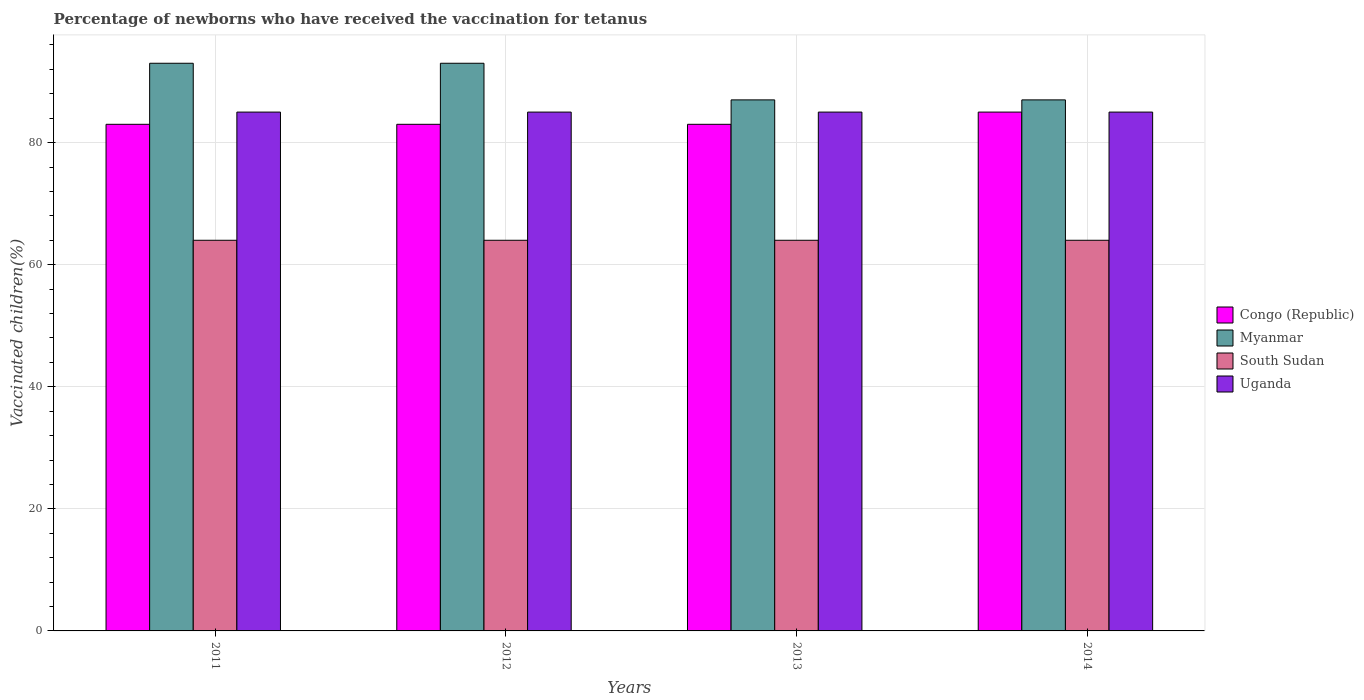Are the number of bars per tick equal to the number of legend labels?
Keep it short and to the point. Yes. Are the number of bars on each tick of the X-axis equal?
Give a very brief answer. Yes. In how many cases, is the number of bars for a given year not equal to the number of legend labels?
Your answer should be compact. 0. What is the percentage of vaccinated children in Congo (Republic) in 2011?
Your answer should be compact. 83. Across all years, what is the maximum percentage of vaccinated children in Uganda?
Keep it short and to the point. 85. Across all years, what is the minimum percentage of vaccinated children in Uganda?
Your answer should be very brief. 85. In which year was the percentage of vaccinated children in Myanmar maximum?
Your answer should be very brief. 2011. What is the total percentage of vaccinated children in Uganda in the graph?
Give a very brief answer. 340. What is the difference between the percentage of vaccinated children in Uganda in 2012 and that in 2013?
Offer a very short reply. 0. What is the ratio of the percentage of vaccinated children in South Sudan in 2013 to that in 2014?
Your answer should be very brief. 1. Is the difference between the percentage of vaccinated children in Uganda in 2011 and 2013 greater than the difference between the percentage of vaccinated children in Congo (Republic) in 2011 and 2013?
Ensure brevity in your answer.  No. What is the difference between the highest and the lowest percentage of vaccinated children in South Sudan?
Offer a very short reply. 0. In how many years, is the percentage of vaccinated children in Myanmar greater than the average percentage of vaccinated children in Myanmar taken over all years?
Ensure brevity in your answer.  2. Is it the case that in every year, the sum of the percentage of vaccinated children in Myanmar and percentage of vaccinated children in Uganda is greater than the sum of percentage of vaccinated children in South Sudan and percentage of vaccinated children in Congo (Republic)?
Your answer should be very brief. Yes. What does the 3rd bar from the left in 2014 represents?
Offer a very short reply. South Sudan. What does the 4th bar from the right in 2011 represents?
Keep it short and to the point. Congo (Republic). Is it the case that in every year, the sum of the percentage of vaccinated children in Congo (Republic) and percentage of vaccinated children in South Sudan is greater than the percentage of vaccinated children in Uganda?
Ensure brevity in your answer.  Yes. How many bars are there?
Make the answer very short. 16. Are all the bars in the graph horizontal?
Keep it short and to the point. No. What is the difference between two consecutive major ticks on the Y-axis?
Keep it short and to the point. 20. Does the graph contain any zero values?
Offer a very short reply. No. Does the graph contain grids?
Keep it short and to the point. Yes. How many legend labels are there?
Keep it short and to the point. 4. What is the title of the graph?
Offer a terse response. Percentage of newborns who have received the vaccination for tetanus. What is the label or title of the Y-axis?
Your answer should be compact. Vaccinated children(%). What is the Vaccinated children(%) of Myanmar in 2011?
Provide a succinct answer. 93. What is the Vaccinated children(%) in South Sudan in 2011?
Give a very brief answer. 64. What is the Vaccinated children(%) in Congo (Republic) in 2012?
Your answer should be very brief. 83. What is the Vaccinated children(%) in Myanmar in 2012?
Your answer should be compact. 93. What is the Vaccinated children(%) in South Sudan in 2012?
Give a very brief answer. 64. What is the Vaccinated children(%) in Myanmar in 2013?
Make the answer very short. 87. What is the Vaccinated children(%) of Congo (Republic) in 2014?
Make the answer very short. 85. What is the Vaccinated children(%) in Myanmar in 2014?
Provide a succinct answer. 87. What is the Vaccinated children(%) of South Sudan in 2014?
Your response must be concise. 64. What is the Vaccinated children(%) in Uganda in 2014?
Make the answer very short. 85. Across all years, what is the maximum Vaccinated children(%) of Myanmar?
Make the answer very short. 93. Across all years, what is the maximum Vaccinated children(%) of South Sudan?
Ensure brevity in your answer.  64. Across all years, what is the maximum Vaccinated children(%) in Uganda?
Provide a succinct answer. 85. Across all years, what is the minimum Vaccinated children(%) of Congo (Republic)?
Your answer should be compact. 83. What is the total Vaccinated children(%) of Congo (Republic) in the graph?
Ensure brevity in your answer.  334. What is the total Vaccinated children(%) of Myanmar in the graph?
Offer a very short reply. 360. What is the total Vaccinated children(%) in South Sudan in the graph?
Provide a succinct answer. 256. What is the total Vaccinated children(%) of Uganda in the graph?
Offer a very short reply. 340. What is the difference between the Vaccinated children(%) of Congo (Republic) in 2011 and that in 2012?
Your response must be concise. 0. What is the difference between the Vaccinated children(%) of Myanmar in 2011 and that in 2012?
Offer a terse response. 0. What is the difference between the Vaccinated children(%) in South Sudan in 2011 and that in 2012?
Ensure brevity in your answer.  0. What is the difference between the Vaccinated children(%) of Uganda in 2011 and that in 2012?
Make the answer very short. 0. What is the difference between the Vaccinated children(%) of South Sudan in 2011 and that in 2014?
Your answer should be compact. 0. What is the difference between the Vaccinated children(%) in Congo (Republic) in 2012 and that in 2013?
Make the answer very short. 0. What is the difference between the Vaccinated children(%) of Myanmar in 2012 and that in 2014?
Offer a very short reply. 6. What is the difference between the Vaccinated children(%) in Uganda in 2012 and that in 2014?
Provide a short and direct response. 0. What is the difference between the Vaccinated children(%) of South Sudan in 2013 and that in 2014?
Ensure brevity in your answer.  0. What is the difference between the Vaccinated children(%) of Uganda in 2013 and that in 2014?
Ensure brevity in your answer.  0. What is the difference between the Vaccinated children(%) of Myanmar in 2011 and the Vaccinated children(%) of South Sudan in 2012?
Your response must be concise. 29. What is the difference between the Vaccinated children(%) of Myanmar in 2011 and the Vaccinated children(%) of Uganda in 2012?
Ensure brevity in your answer.  8. What is the difference between the Vaccinated children(%) in Congo (Republic) in 2011 and the Vaccinated children(%) in Myanmar in 2013?
Make the answer very short. -4. What is the difference between the Vaccinated children(%) in Myanmar in 2011 and the Vaccinated children(%) in Uganda in 2013?
Give a very brief answer. 8. What is the difference between the Vaccinated children(%) in South Sudan in 2011 and the Vaccinated children(%) in Uganda in 2013?
Offer a very short reply. -21. What is the difference between the Vaccinated children(%) of Congo (Republic) in 2011 and the Vaccinated children(%) of Myanmar in 2014?
Provide a succinct answer. -4. What is the difference between the Vaccinated children(%) in Congo (Republic) in 2011 and the Vaccinated children(%) in Uganda in 2014?
Provide a succinct answer. -2. What is the difference between the Vaccinated children(%) of Myanmar in 2011 and the Vaccinated children(%) of South Sudan in 2014?
Your answer should be very brief. 29. What is the difference between the Vaccinated children(%) of Myanmar in 2011 and the Vaccinated children(%) of Uganda in 2014?
Your answer should be very brief. 8. What is the difference between the Vaccinated children(%) of South Sudan in 2011 and the Vaccinated children(%) of Uganda in 2014?
Your answer should be compact. -21. What is the difference between the Vaccinated children(%) in Congo (Republic) in 2012 and the Vaccinated children(%) in Myanmar in 2013?
Your answer should be compact. -4. What is the difference between the Vaccinated children(%) in Congo (Republic) in 2012 and the Vaccinated children(%) in Uganda in 2013?
Ensure brevity in your answer.  -2. What is the difference between the Vaccinated children(%) in Congo (Republic) in 2012 and the Vaccinated children(%) in Uganda in 2014?
Ensure brevity in your answer.  -2. What is the difference between the Vaccinated children(%) in Myanmar in 2012 and the Vaccinated children(%) in Uganda in 2014?
Ensure brevity in your answer.  8. What is the difference between the Vaccinated children(%) of South Sudan in 2012 and the Vaccinated children(%) of Uganda in 2014?
Offer a very short reply. -21. What is the difference between the Vaccinated children(%) of Congo (Republic) in 2013 and the Vaccinated children(%) of Myanmar in 2014?
Give a very brief answer. -4. What is the difference between the Vaccinated children(%) of Myanmar in 2013 and the Vaccinated children(%) of Uganda in 2014?
Offer a very short reply. 2. What is the difference between the Vaccinated children(%) in South Sudan in 2013 and the Vaccinated children(%) in Uganda in 2014?
Provide a succinct answer. -21. What is the average Vaccinated children(%) of Congo (Republic) per year?
Keep it short and to the point. 83.5. What is the average Vaccinated children(%) in Myanmar per year?
Keep it short and to the point. 90. What is the average Vaccinated children(%) in South Sudan per year?
Make the answer very short. 64. In the year 2011, what is the difference between the Vaccinated children(%) in Congo (Republic) and Vaccinated children(%) in South Sudan?
Provide a short and direct response. 19. In the year 2011, what is the difference between the Vaccinated children(%) of Myanmar and Vaccinated children(%) of Uganda?
Offer a terse response. 8. In the year 2011, what is the difference between the Vaccinated children(%) of South Sudan and Vaccinated children(%) of Uganda?
Ensure brevity in your answer.  -21. In the year 2012, what is the difference between the Vaccinated children(%) in Congo (Republic) and Vaccinated children(%) in Myanmar?
Give a very brief answer. -10. In the year 2012, what is the difference between the Vaccinated children(%) of Congo (Republic) and Vaccinated children(%) of Uganda?
Give a very brief answer. -2. In the year 2012, what is the difference between the Vaccinated children(%) of Myanmar and Vaccinated children(%) of South Sudan?
Offer a terse response. 29. In the year 2012, what is the difference between the Vaccinated children(%) in South Sudan and Vaccinated children(%) in Uganda?
Offer a terse response. -21. In the year 2013, what is the difference between the Vaccinated children(%) of Congo (Republic) and Vaccinated children(%) of South Sudan?
Provide a short and direct response. 19. In the year 2013, what is the difference between the Vaccinated children(%) in Congo (Republic) and Vaccinated children(%) in Uganda?
Give a very brief answer. -2. In the year 2013, what is the difference between the Vaccinated children(%) of Myanmar and Vaccinated children(%) of Uganda?
Provide a succinct answer. 2. In the year 2013, what is the difference between the Vaccinated children(%) of South Sudan and Vaccinated children(%) of Uganda?
Offer a very short reply. -21. In the year 2014, what is the difference between the Vaccinated children(%) in Myanmar and Vaccinated children(%) in South Sudan?
Provide a succinct answer. 23. In the year 2014, what is the difference between the Vaccinated children(%) of Myanmar and Vaccinated children(%) of Uganda?
Provide a succinct answer. 2. In the year 2014, what is the difference between the Vaccinated children(%) in South Sudan and Vaccinated children(%) in Uganda?
Offer a terse response. -21. What is the ratio of the Vaccinated children(%) of Congo (Republic) in 2011 to that in 2012?
Keep it short and to the point. 1. What is the ratio of the Vaccinated children(%) in Myanmar in 2011 to that in 2012?
Offer a terse response. 1. What is the ratio of the Vaccinated children(%) of South Sudan in 2011 to that in 2012?
Your response must be concise. 1. What is the ratio of the Vaccinated children(%) in Congo (Republic) in 2011 to that in 2013?
Your answer should be very brief. 1. What is the ratio of the Vaccinated children(%) in Myanmar in 2011 to that in 2013?
Your answer should be compact. 1.07. What is the ratio of the Vaccinated children(%) of South Sudan in 2011 to that in 2013?
Offer a terse response. 1. What is the ratio of the Vaccinated children(%) in Congo (Republic) in 2011 to that in 2014?
Provide a succinct answer. 0.98. What is the ratio of the Vaccinated children(%) in Myanmar in 2011 to that in 2014?
Your answer should be compact. 1.07. What is the ratio of the Vaccinated children(%) in South Sudan in 2011 to that in 2014?
Provide a short and direct response. 1. What is the ratio of the Vaccinated children(%) in Congo (Republic) in 2012 to that in 2013?
Provide a succinct answer. 1. What is the ratio of the Vaccinated children(%) of Myanmar in 2012 to that in 2013?
Offer a terse response. 1.07. What is the ratio of the Vaccinated children(%) in South Sudan in 2012 to that in 2013?
Make the answer very short. 1. What is the ratio of the Vaccinated children(%) in Congo (Republic) in 2012 to that in 2014?
Provide a succinct answer. 0.98. What is the ratio of the Vaccinated children(%) of Myanmar in 2012 to that in 2014?
Your response must be concise. 1.07. What is the ratio of the Vaccinated children(%) of South Sudan in 2012 to that in 2014?
Give a very brief answer. 1. What is the ratio of the Vaccinated children(%) of Uganda in 2012 to that in 2014?
Keep it short and to the point. 1. What is the ratio of the Vaccinated children(%) of Congo (Republic) in 2013 to that in 2014?
Ensure brevity in your answer.  0.98. What is the ratio of the Vaccinated children(%) in South Sudan in 2013 to that in 2014?
Provide a succinct answer. 1. What is the ratio of the Vaccinated children(%) in Uganda in 2013 to that in 2014?
Your answer should be very brief. 1. What is the difference between the highest and the second highest Vaccinated children(%) of Myanmar?
Give a very brief answer. 0. What is the difference between the highest and the second highest Vaccinated children(%) in South Sudan?
Make the answer very short. 0. What is the difference between the highest and the lowest Vaccinated children(%) of South Sudan?
Give a very brief answer. 0. 